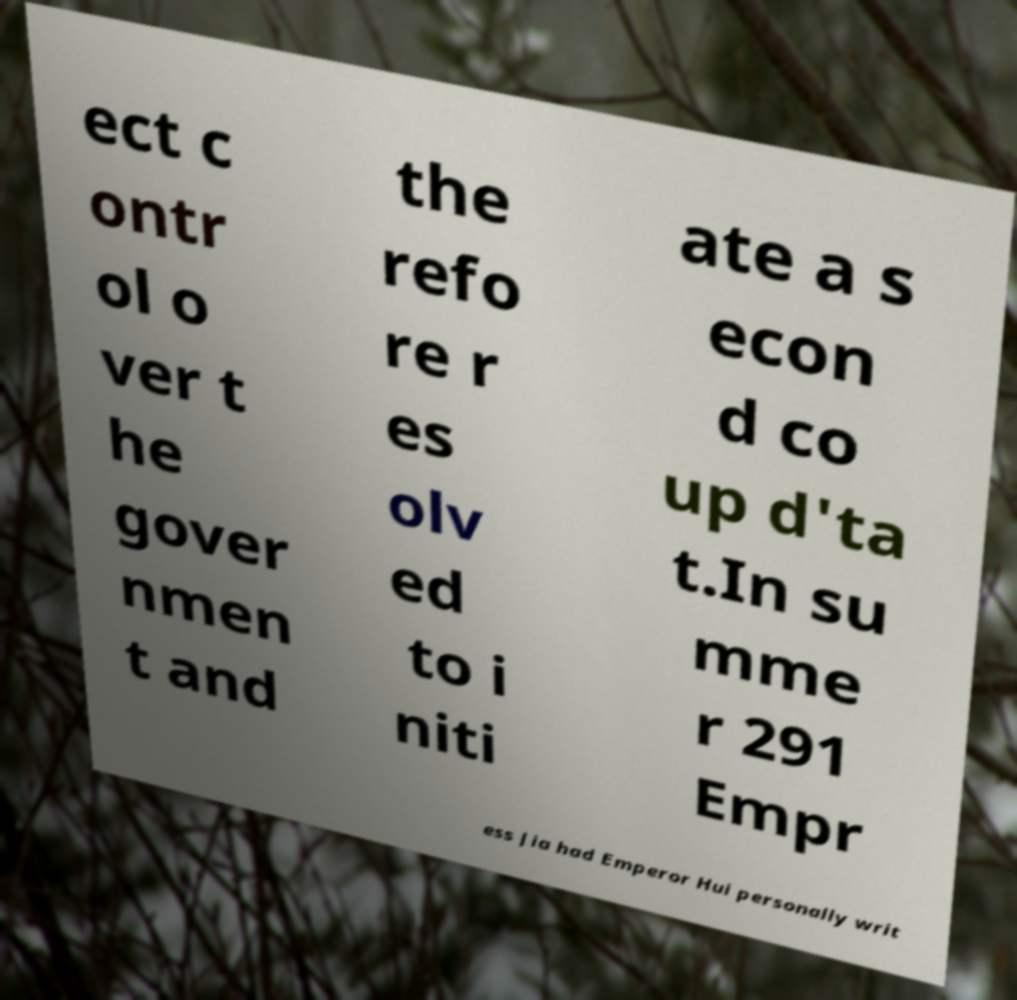Could you extract and type out the text from this image? ect c ontr ol o ver t he gover nmen t and the refo re r es olv ed to i niti ate a s econ d co up d'ta t.In su mme r 291 Empr ess Jia had Emperor Hui personally writ 